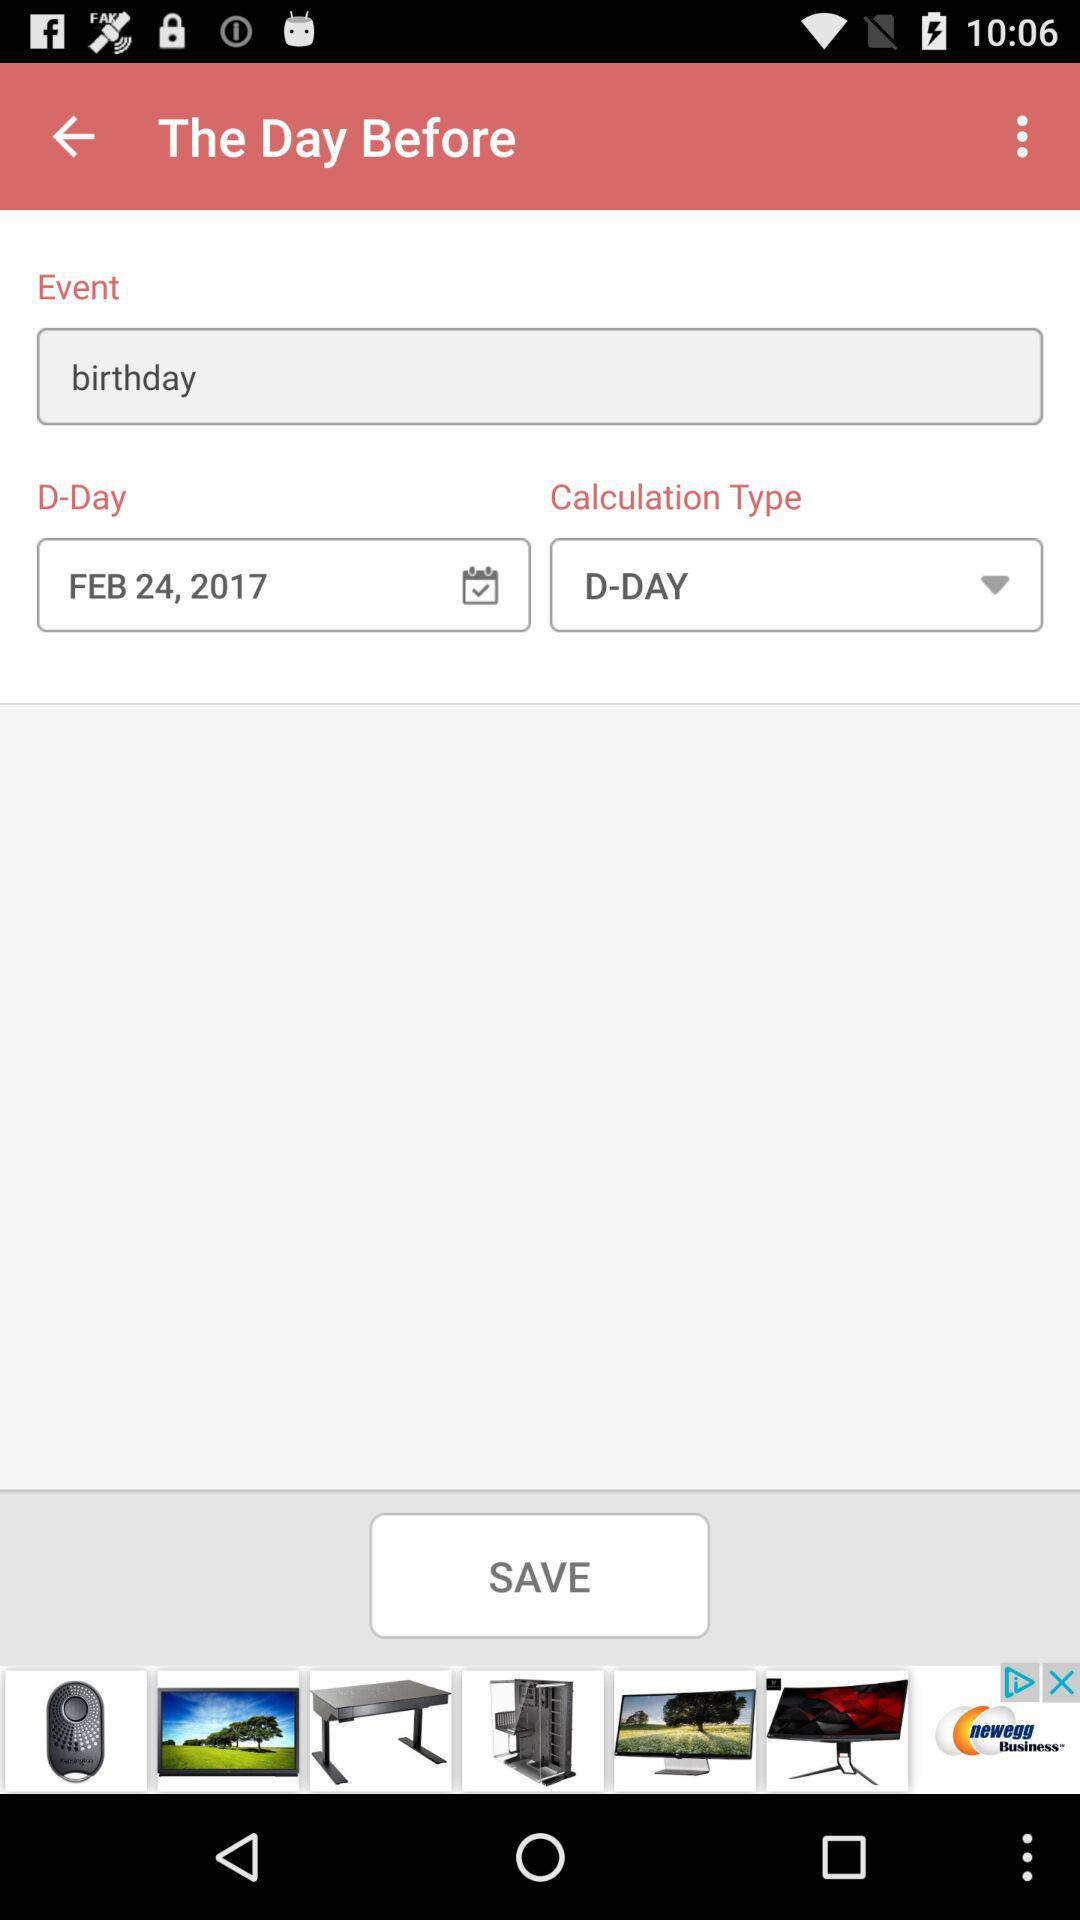Which option is selected for the calculation type? The selected option for the calculation type is "D-DAY". 